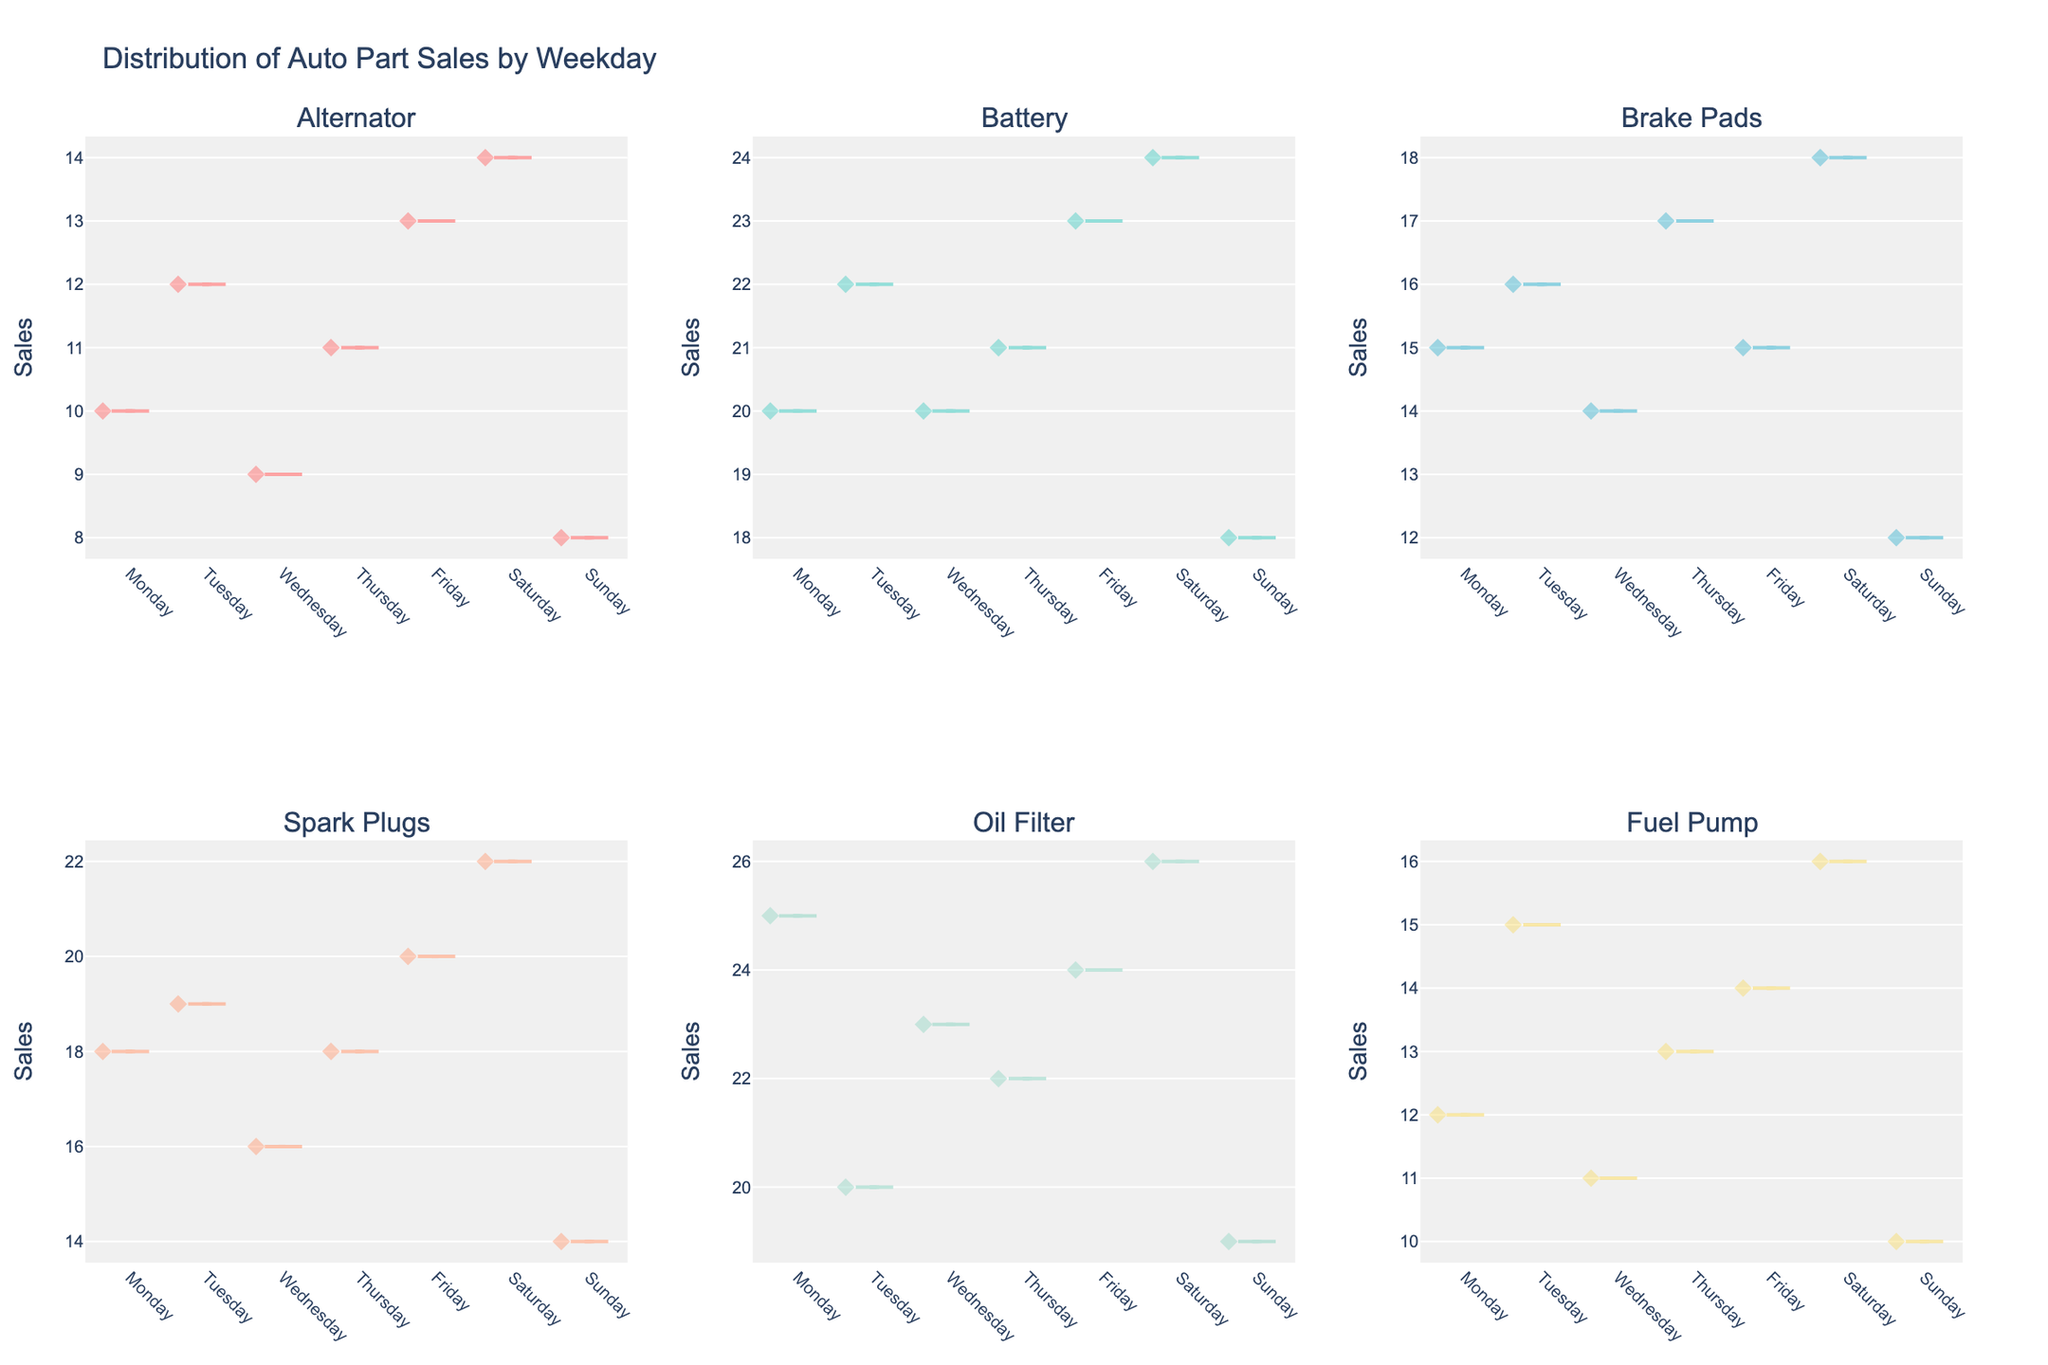What's the title of the figure? The title of the figure is usually located at the top of the plot, written in larger font size. By referring to the plot, you can easily read the title.
Answer: Distribution of Auto Part Sales by Weekday What are the weekdays shown on the x-axis? By looking at the x-axis of any subplot, we can observe the labels which represent the days of the week.
Answer: Monday, Tuesday, Wednesday, Thursday, Friday, Saturday, Sunday What's the range of sales values on the y-axis? The y-axis displays the range of sales values for the different auto parts, visible along all subplots. By checking any subplot, you can determine the minimum and maximum values shown.
Answer: 8 to 26 Which part type shows the highest sales on Saturday? By looking at the subplot specifically for Saturday's sales, we can see which part type reached the highest point on the y-axis.
Answer: Oil Filter How does the sales distribution for Spark Plugs on Friday compare to Monday? To answer this, compare the spread and central tendency (mean line) of the violin plots for Spark Plugs on Monday and Friday. The spread indicates variability, and the mean lines indicate average sales.
Answer: Wider spread on Friday, higher mean on Friday Which part type has the lowest mean sales on Sunday? Check the location of the mean lines in the Sunday subplot for each part type, and identify the one that is at the lowest position on the y-axis.
Answer: Alternator What's the interquartile range (IQR) of Brake Pads' sales on Thursday? The IQR is the range within the middle 50% of the data. In the violin plot, this is often depicted as the width of the plot at the box position in the center. For Brake Pads on Thursday, estimate the distance between the upper and lower parts of the box.
Answer: Approximately 16 to 17 What pattern do you observe in Battery sales throughout the week? Look across the subplots for Battery sales from Monday to Sunday and observe any trends or patterns in the distribution of sales. Note changes in the spread, mean lines, and any outliers.
Answer: Generally increasing from Sunday to Saturday Which day has the most consistent sales for Fuel Pump? Consistency can be determined by the narrowness of the distribution in the violin plot. Look at each day's Fuel Pump plot and assess the width of the distribution.
Answer: Tuesday Are there any outliers in the Sales data for Oil Filters on Wednesday? Outliers would appear as individual points outside the main body of the violin plot. Check the Wednesday subplot for Oil Filters to see if any dots lie outside the primary shape.
Answer: No 